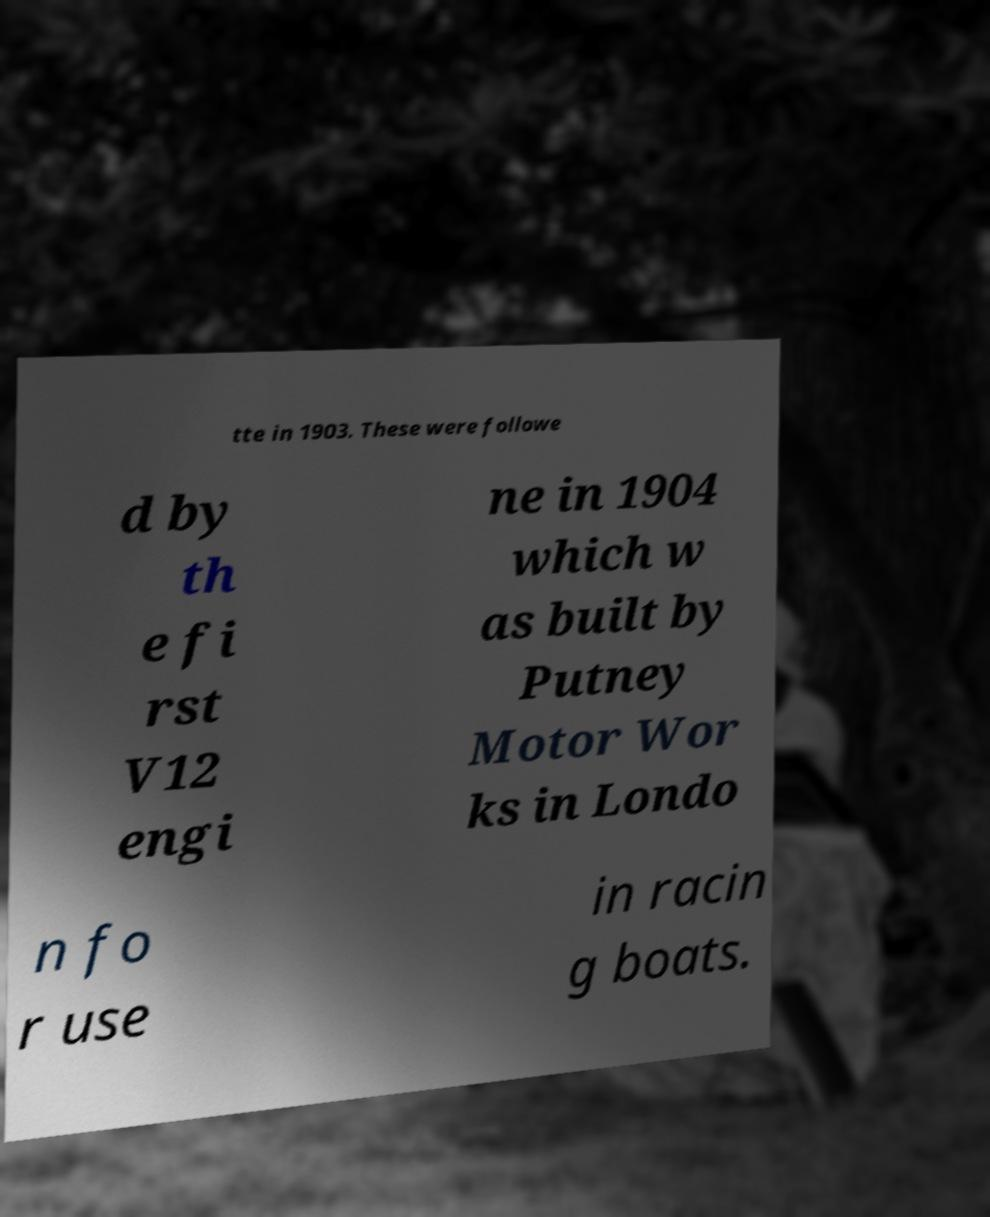Could you extract and type out the text from this image? tte in 1903. These were followe d by th e fi rst V12 engi ne in 1904 which w as built by Putney Motor Wor ks in Londo n fo r use in racin g boats. 